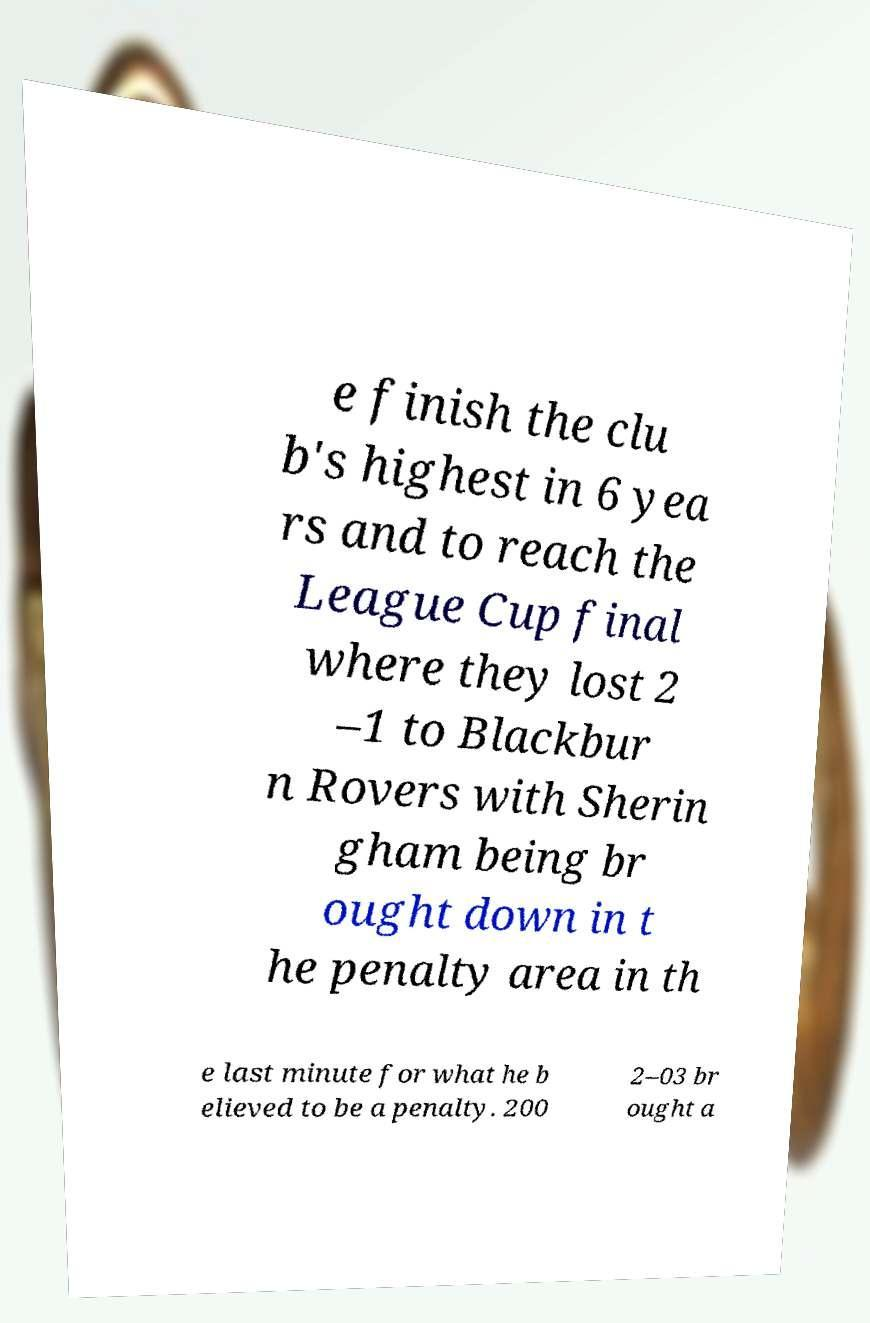Can you accurately transcribe the text from the provided image for me? e finish the clu b's highest in 6 yea rs and to reach the League Cup final where they lost 2 –1 to Blackbur n Rovers with Sherin gham being br ought down in t he penalty area in th e last minute for what he b elieved to be a penalty. 200 2–03 br ought a 